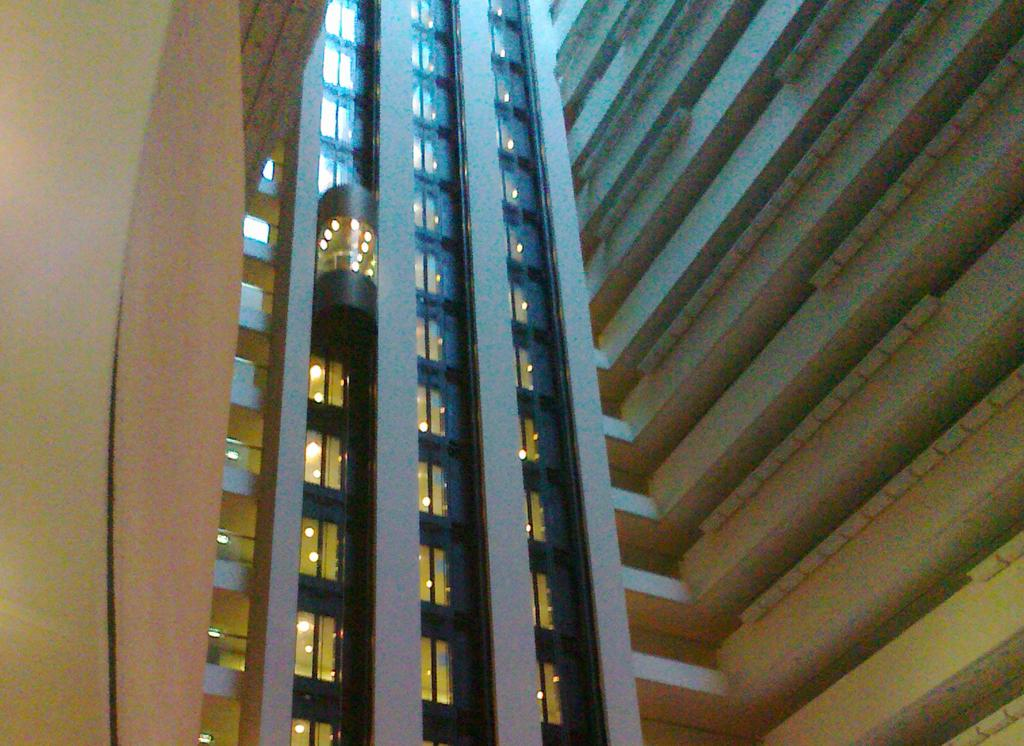What type of structure is visible in the image? There is a building in the image. What feature of the building can be seen in the image? There is a lift in the building. Are there any icicles hanging from the building in the image? There is no mention of icicles in the provided facts, and therefore we cannot determine if any are present in the image. 